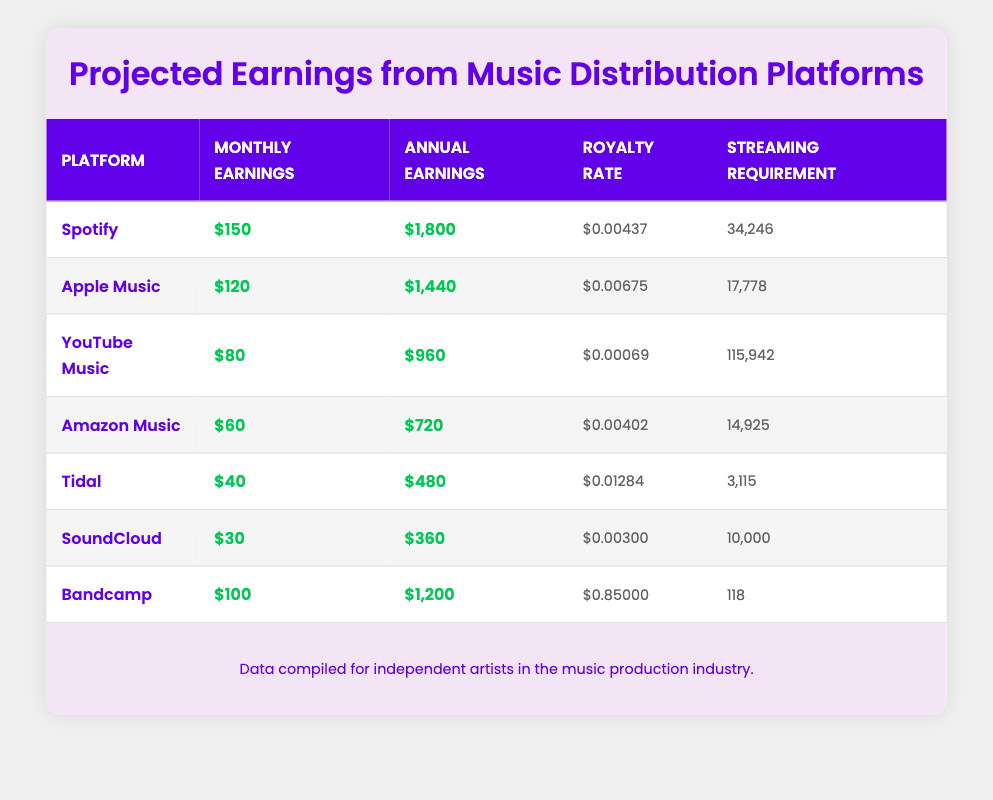What are the projected annual earnings from Spotify? In the table, Spotify's annual earnings are listed under the "Annual Earnings" column. Looking directly at that entry, we find that Spotify's projected annual earnings are $1,800.
Answer: $1,800 Which platform has the highest royalty rate? The "Royalty Rate" column shows the rates for all platforms. Scanning through the values, Bandcamp has a royalty rate of $0.85000, which is higher than any other platform in the table.
Answer: Bandcamp What is the total monthly earnings from Apple Music and Amazon Music combined? The monthly earnings for Apple Music are $120 and for Amazon Music are $60. Adding these amounts together (120 + 60) gives us a total of $180 in monthly earnings.
Answer: $180 How many streams are required to earn $40 on Tidal? The table provides the streaming requirement for each platform. For Tidal, it is shown as 3,115 streams. Therefore, to earn $40 on Tidal, an artist needs 3,115 streams.
Answer: 3,115 Is the projected earnings from YouTube Music more than $1,000 annually? The annual earnings for YouTube Music is listed as $960. Since $960 is less than $1,000, the statement is false.
Answer: No What is the average monthly earnings across all the platforms provided? The monthly earnings for each platform are $150 (Spotify), $120 (Apple Music), $80 (YouTube Music), $60 (Amazon Music), $40 (Tidal), $30 (SoundCloud), and $100 (Bandcamp). Calculating the sum gives 150 + 120 + 80 + 60 + 40 + 30 + 100 = 580. There are 7 platforms, so the average is 580/7 = approximately $82.86.
Answer: $82.86 Which platform has the lowest annual earnings? Referring to the "Annual Earnings" column, we see that SoundCloud has the lowest value of $360. This indicates that it earns less annually compared to the other platforms.
Answer: SoundCloud What is the difference in monthly earnings between Spotify and Bandcamp? The monthly earnings for Spotify is $150 and for Bandcamp is $100. The difference can be calculated by subtracting Bandcamp’s earnings from Spotify’s earnings (150 - 100), which equals $50.
Answer: $50 